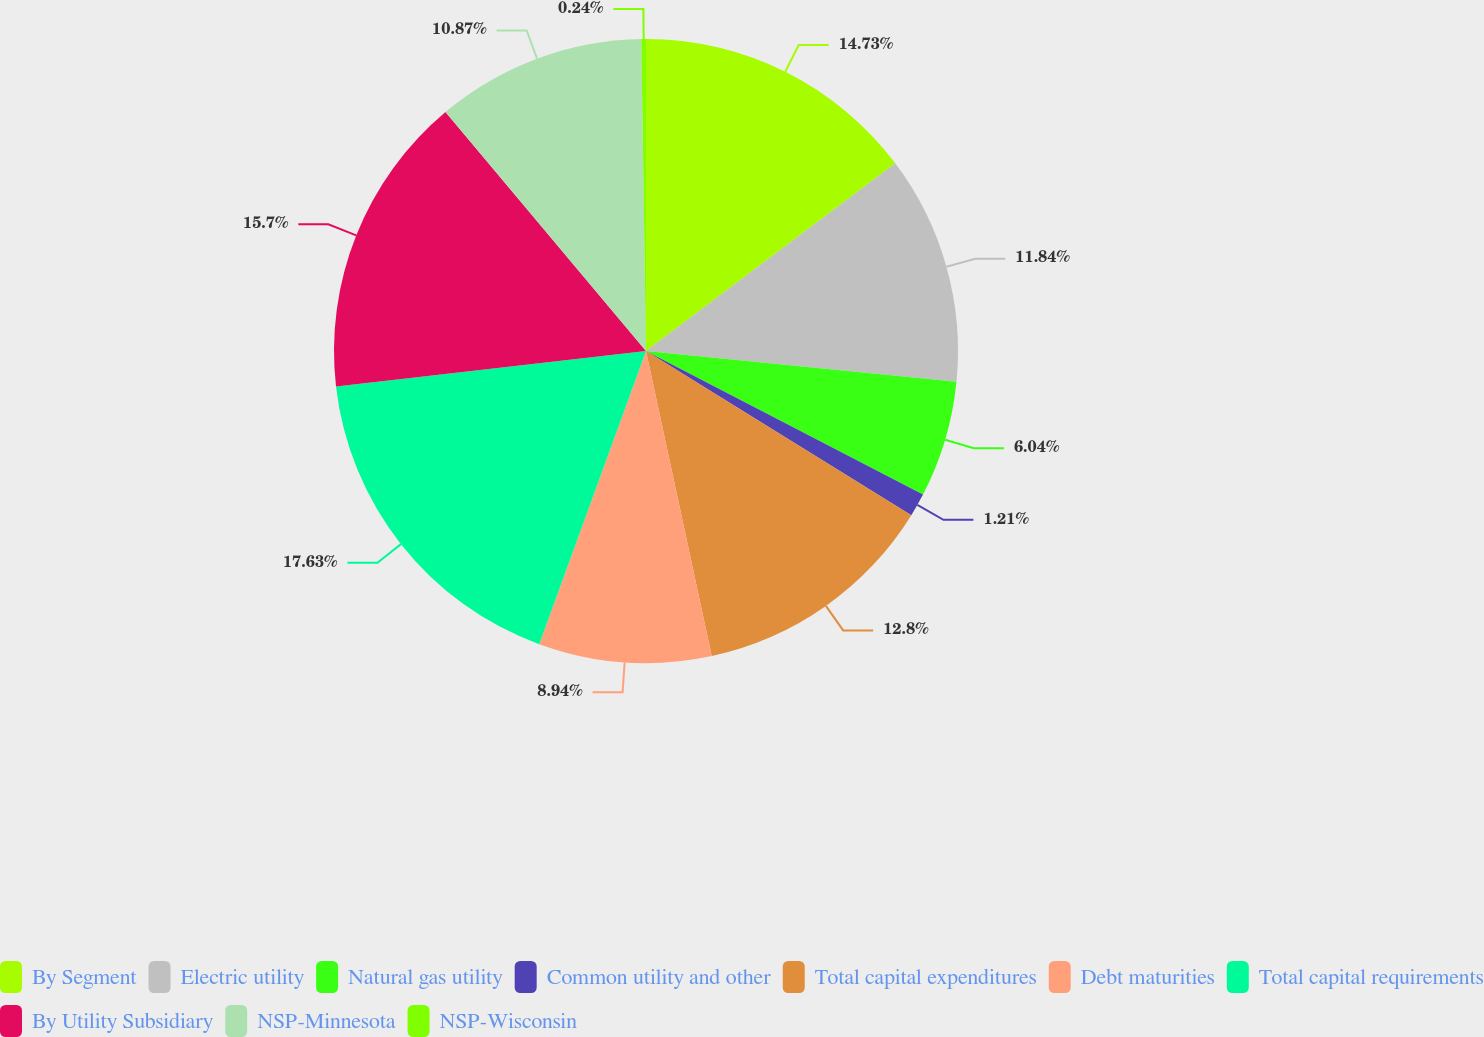<chart> <loc_0><loc_0><loc_500><loc_500><pie_chart><fcel>By Segment<fcel>Electric utility<fcel>Natural gas utility<fcel>Common utility and other<fcel>Total capital expenditures<fcel>Debt maturities<fcel>Total capital requirements<fcel>By Utility Subsidiary<fcel>NSP-Minnesota<fcel>NSP-Wisconsin<nl><fcel>14.73%<fcel>11.84%<fcel>6.04%<fcel>1.21%<fcel>12.8%<fcel>8.94%<fcel>17.63%<fcel>15.7%<fcel>10.87%<fcel>0.24%<nl></chart> 